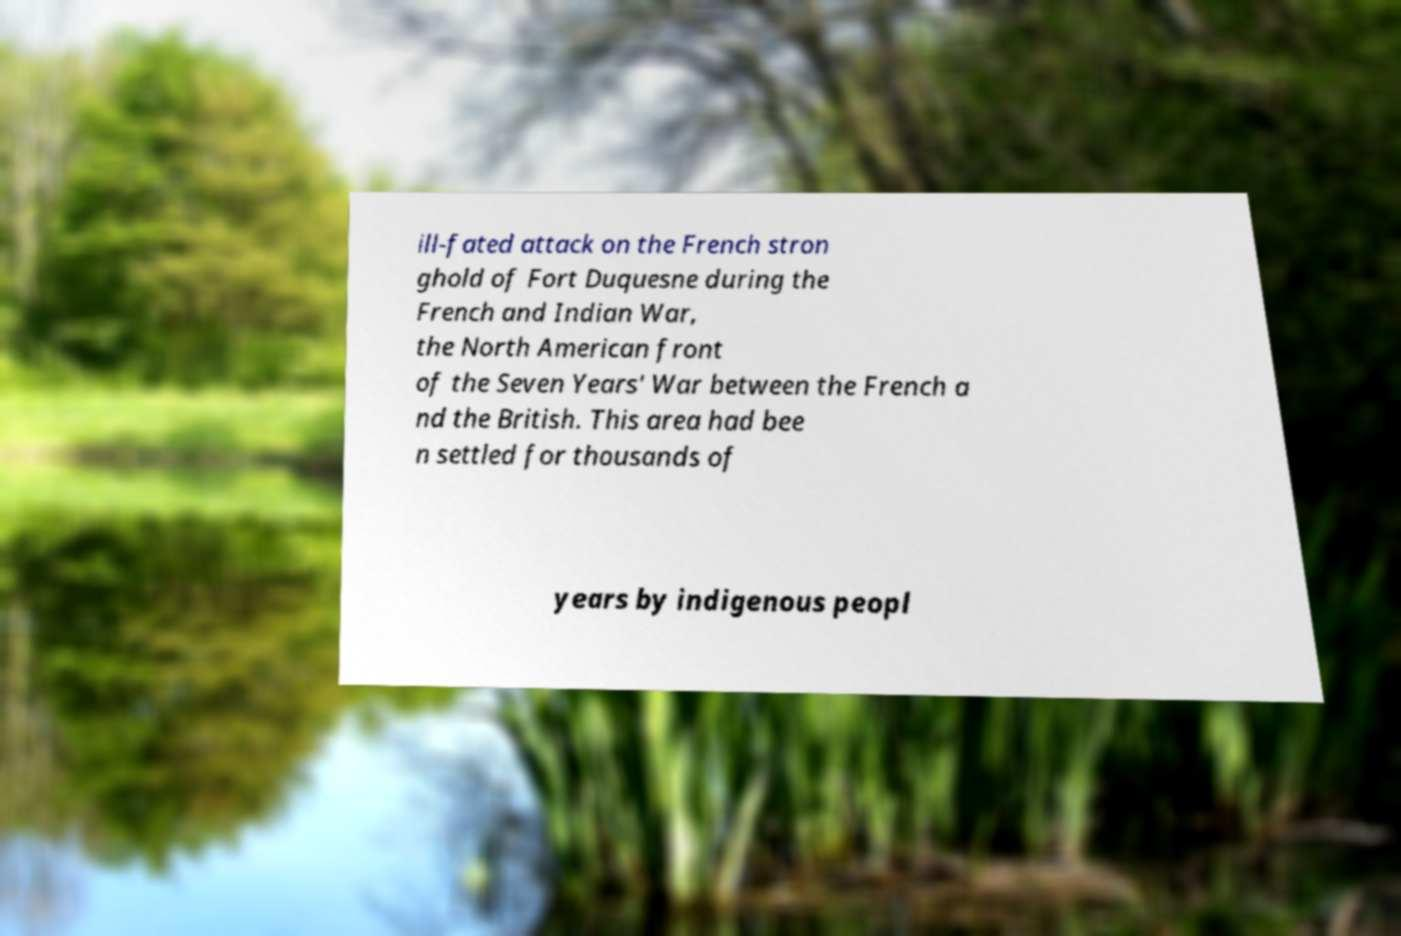There's text embedded in this image that I need extracted. Can you transcribe it verbatim? ill-fated attack on the French stron ghold of Fort Duquesne during the French and Indian War, the North American front of the Seven Years' War between the French a nd the British. This area had bee n settled for thousands of years by indigenous peopl 